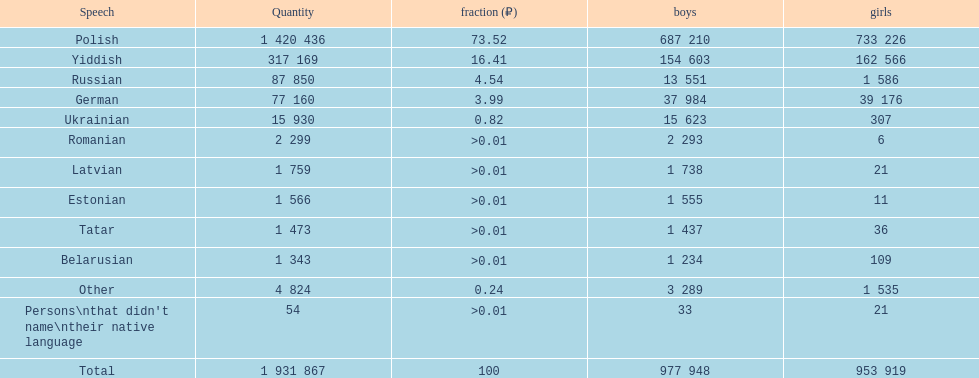Which language had the smallest number of females speaking it. Romanian. 